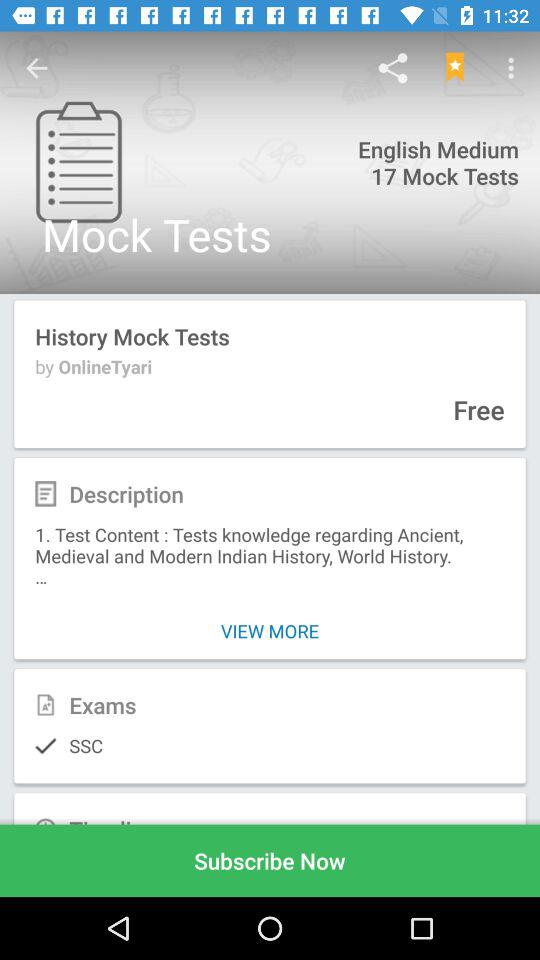What is the name of the user? The user name is John. 